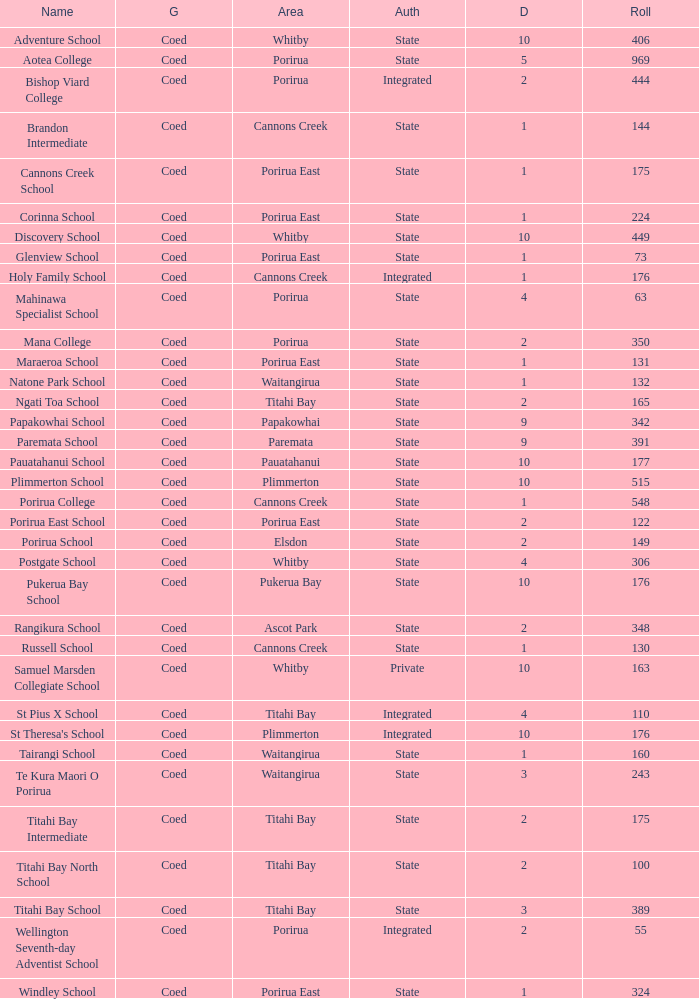What was the decile of Samuel Marsden Collegiate School in Whitby, when it had a roll higher than 163? 0.0. 